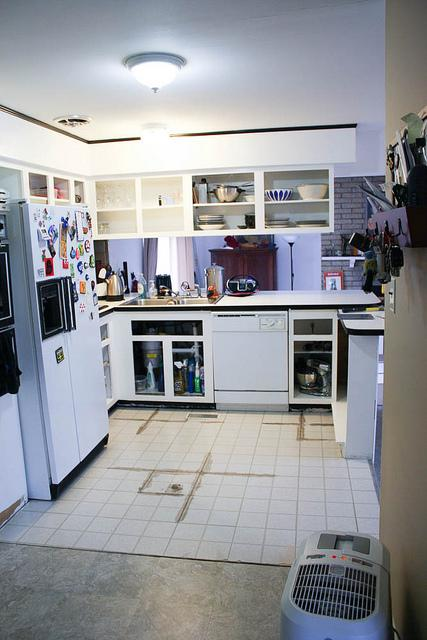What type of floor has been laid in the kitchen?

Choices:
A) tyle
B) carpet
C) linoleum
D) hardwood hardwood 